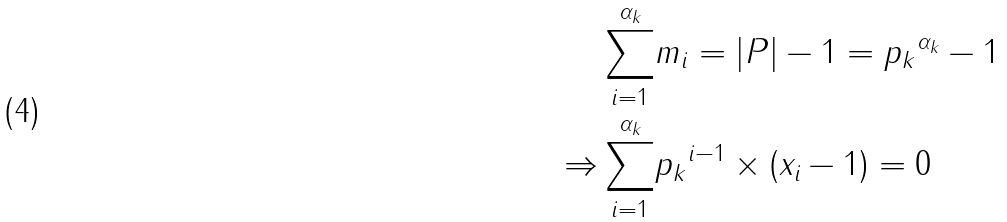<formula> <loc_0><loc_0><loc_500><loc_500>& \, \underset { i = 1 } { \overset { \alpha _ { k } } { \sum } } m _ { i } = | P | - 1 = { p _ { k } } ^ { \alpha _ { k } } - 1 \\ \Rightarrow & \, \underset { i = 1 } { \overset { \alpha _ { k } } { \sum } } { p _ { k } } ^ { i - 1 } \times ( x _ { i } - 1 ) = 0</formula> 